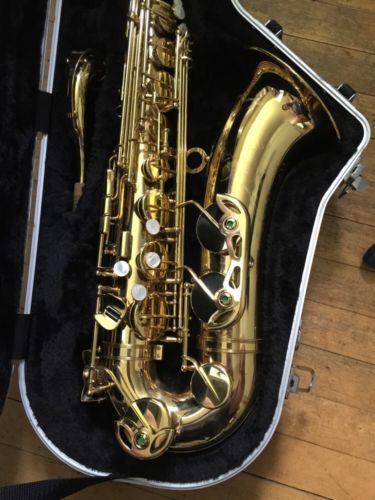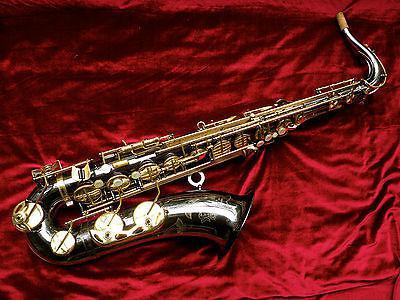The first image is the image on the left, the second image is the image on the right. Assess this claim about the two images: "In at least one image there is a single bras saxophone  with the mouth section tiped left froward with the horn part almost parrellal to the ground.". Correct or not? Answer yes or no. Yes. The first image is the image on the left, the second image is the image on the right. Given the left and right images, does the statement "Each saxophone is displayed nearly vertically with its bell facing rightward, but the saxophone on the right is a brighter, yellower gold color." hold true? Answer yes or no. No. 